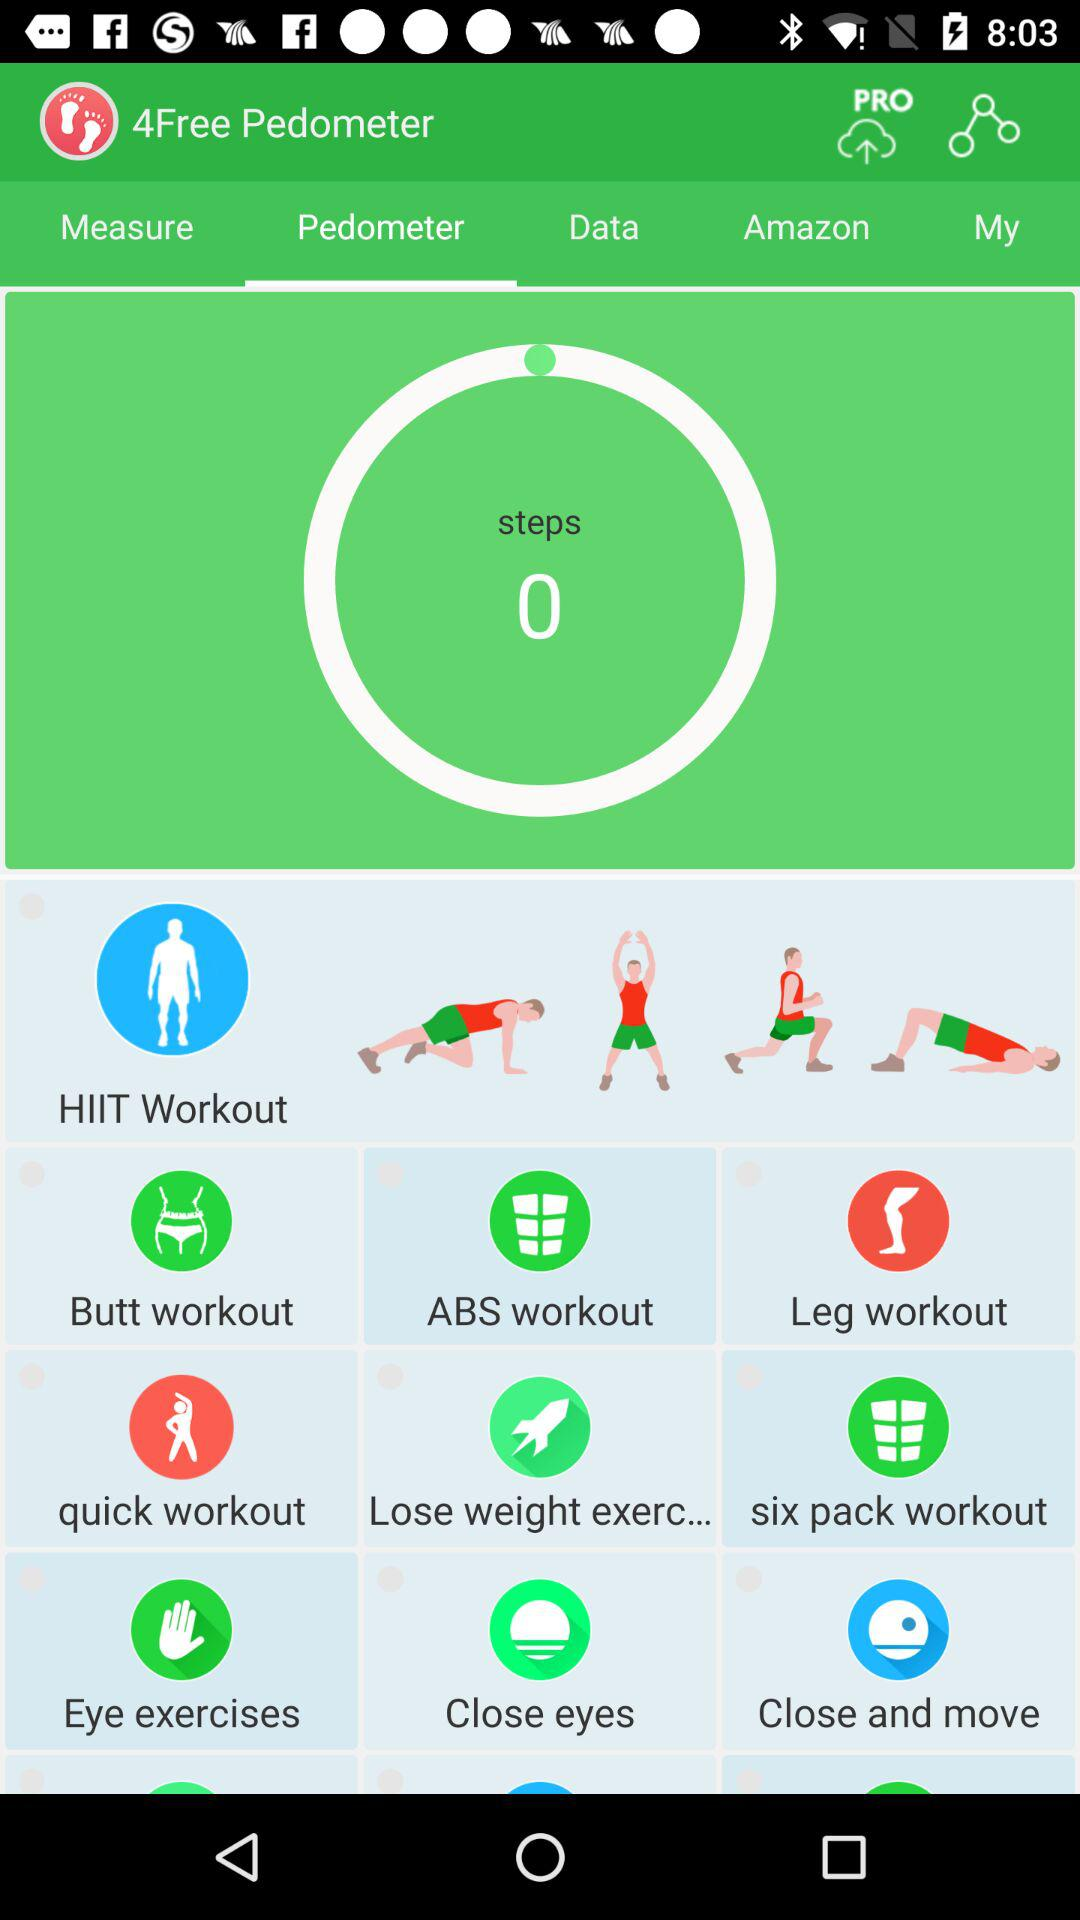Which tab am I using? You are using the "Pedometer" tab. 